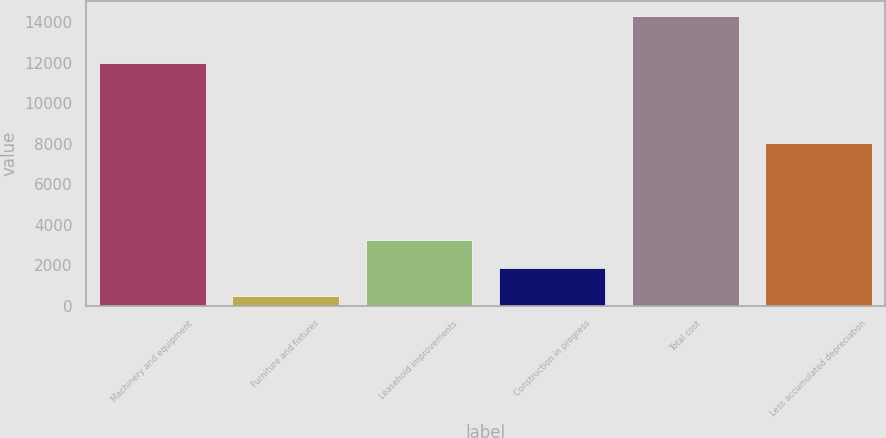<chart> <loc_0><loc_0><loc_500><loc_500><bar_chart><fcel>Machinery and equipment<fcel>Furniture and fixtures<fcel>Leasehold improvements<fcel>Construction in progress<fcel>Total cost<fcel>Less accumulated depreciation<nl><fcel>11996<fcel>489<fcel>3255.6<fcel>1872.3<fcel>14322<fcel>8049<nl></chart> 